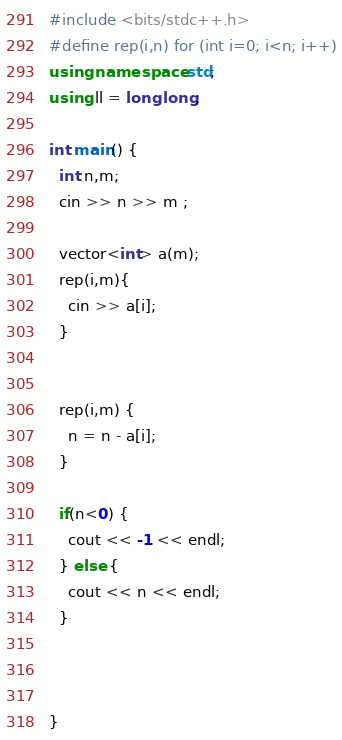<code> <loc_0><loc_0><loc_500><loc_500><_C++_>#include <bits/stdc++.h>
#define rep(i,n) for (int i=0; i<n; i++)
using namespace std;
using ll = long long;

int main() {
  int n,m;
  cin >> n >> m ;
  
  vector<int> a(m);
  rep(i,m){
    cin >> a[i];
  }

  
  rep(i,m) {
    n = n - a[i];
  }

  if(n<0) {
    cout << -1 << endl;
  } else {
    cout << n << endl;
  }
  


}
</code> 